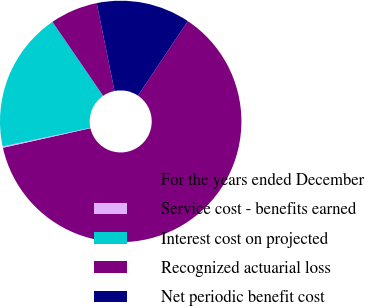Convert chart. <chart><loc_0><loc_0><loc_500><loc_500><pie_chart><fcel>For the years ended December<fcel>Service cost - benefits earned<fcel>Interest cost on projected<fcel>Recognized actuarial loss<fcel>Net periodic benefit cost<nl><fcel>62.11%<fcel>0.18%<fcel>18.76%<fcel>6.38%<fcel>12.57%<nl></chart> 